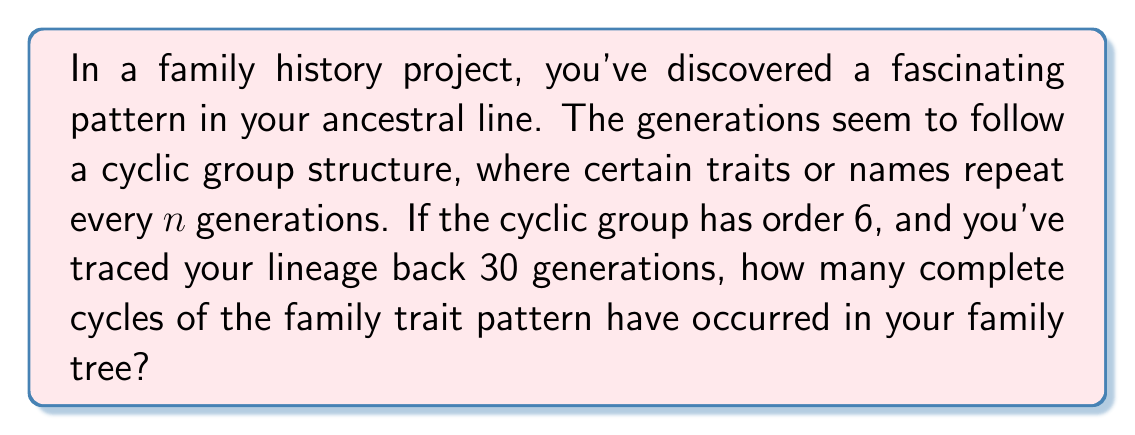Solve this math problem. To solve this problem, we need to understand the concept of cyclic groups and how they relate to the generations in a family tree. Let's break it down step-by-step:

1) A cyclic group is a group that can be generated by a single element. In this case, the group represents the pattern of traits or names that repeat in the family tree.

2) The order of the cyclic group is 6, which means the pattern repeats every 6 generations.

3) We can represent this mathematically as:

   $$C_6 = \{e, g, g^2, g^3, g^4, g^5\}$$

   where $e$ is the identity element and $g$ is the generator of the group.

4) The number of generations traced back is 30.

5) To find the number of complete cycles, we need to divide the total number of generations by the order of the cyclic group:

   $$\text{Number of cycles} = \frac{\text{Total generations}}{\text{Order of cyclic group}}$$

6) Substituting our values:

   $$\text{Number of cycles} = \frac{30}{6} = 5$$

Therefore, 5 complete cycles of the family trait pattern have occurred in the 30 generations of the family tree.

This concept can be very useful in genealogy research, as it helps identify recurring patterns and potentially predict traits or names in earlier, undocumented generations.
Answer: 5 complete cycles 